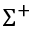<formula> <loc_0><loc_0><loc_500><loc_500>\Sigma ^ { + }</formula> 